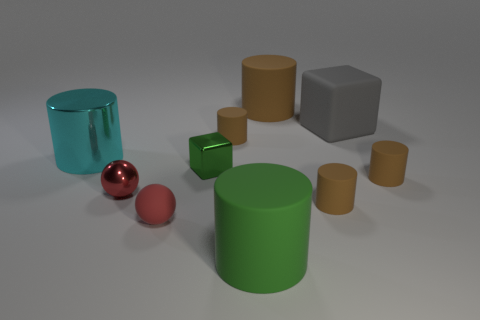Do the cyan cylinder and the red matte object have the same size?
Give a very brief answer. No. Do the large object that is in front of the red metallic object and the large metal cylinder have the same color?
Your response must be concise. No. How many large brown matte objects are to the right of the big cyan cylinder?
Make the answer very short. 1. Are there more big red cylinders than red objects?
Offer a terse response. No. The tiny object that is both on the right side of the green cylinder and behind the small red metal object has what shape?
Provide a succinct answer. Cylinder. Is there a big brown cylinder?
Provide a succinct answer. Yes. What is the material of the large green thing that is the same shape as the big cyan thing?
Make the answer very short. Rubber. There is a green thing left of the small matte object that is behind the large cyan cylinder in front of the matte block; what shape is it?
Keep it short and to the point. Cube. There is a cylinder that is the same color as the shiny cube; what is its material?
Your answer should be compact. Rubber. What number of green matte objects are the same shape as the large cyan object?
Your answer should be very brief. 1. 